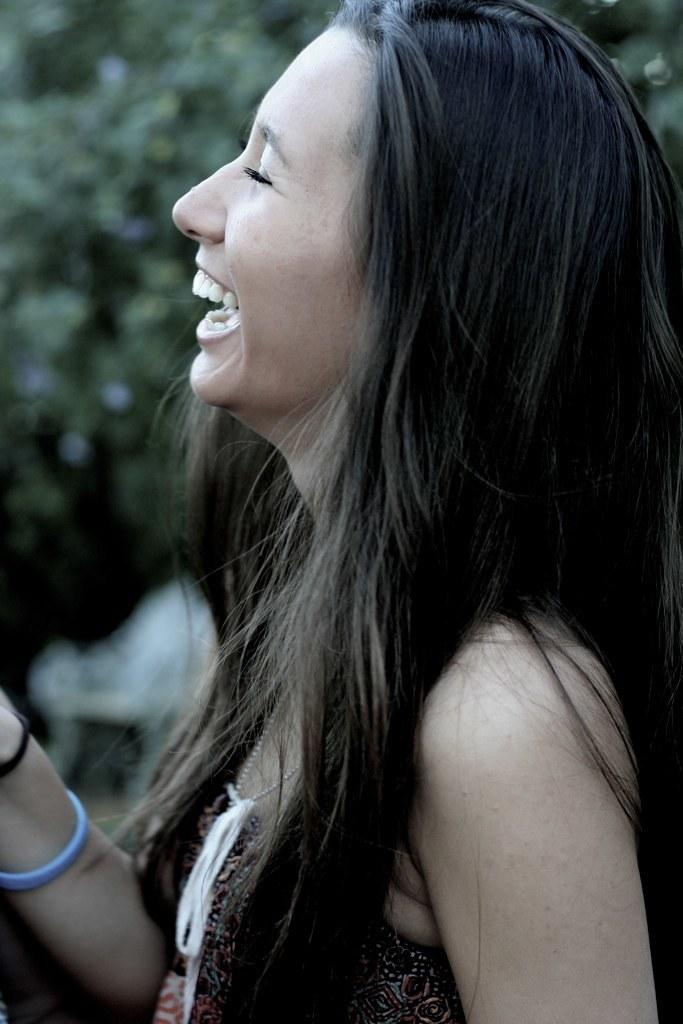What is the main subject in the foreground of the image? There is a woman in the foreground of the image. What is the woman doing in the image? The woman is smiling in the image. What can be seen in the background of the image? There are trees in the background of the image. What type of insurance does the woman have in the image? There is no information about insurance in the image; it only shows a woman smiling with trees in the background. 